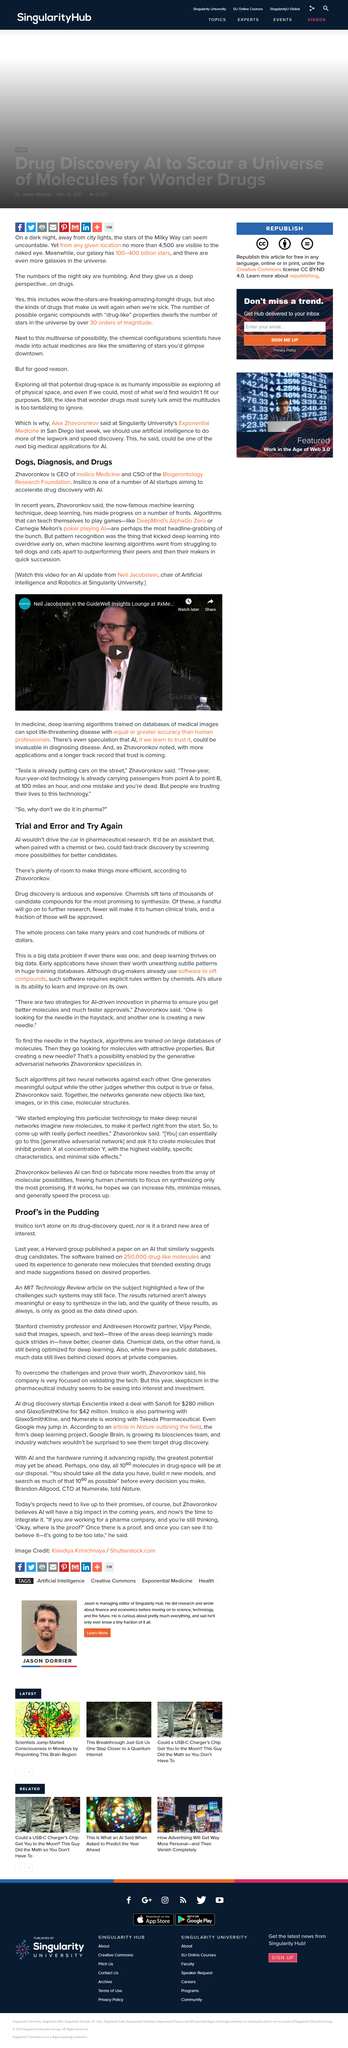Indicate a few pertinent items in this graphic. Based on its experience, the AI software generated new molecules by blending existing drugs, and made suggestions based on desired properties. During the drug discovery process, chemists screen tens of thousands of candidate compounds in order to identify potential medicines. The AI software was trained on a total of 250,000 drug-like molecules. Insilico is a AI startup that aims to accelerate drug discovery through the use of advanced machine learning algorithms and other artificial intelligence technologies. It is one of many such startups in the industry, working to harness the power of AI to improve the efficiency and effectiveness of the drug discovery process. Neil Jacobstein is the chair of Artificial Intelligence and Robotics at Singularity University. 